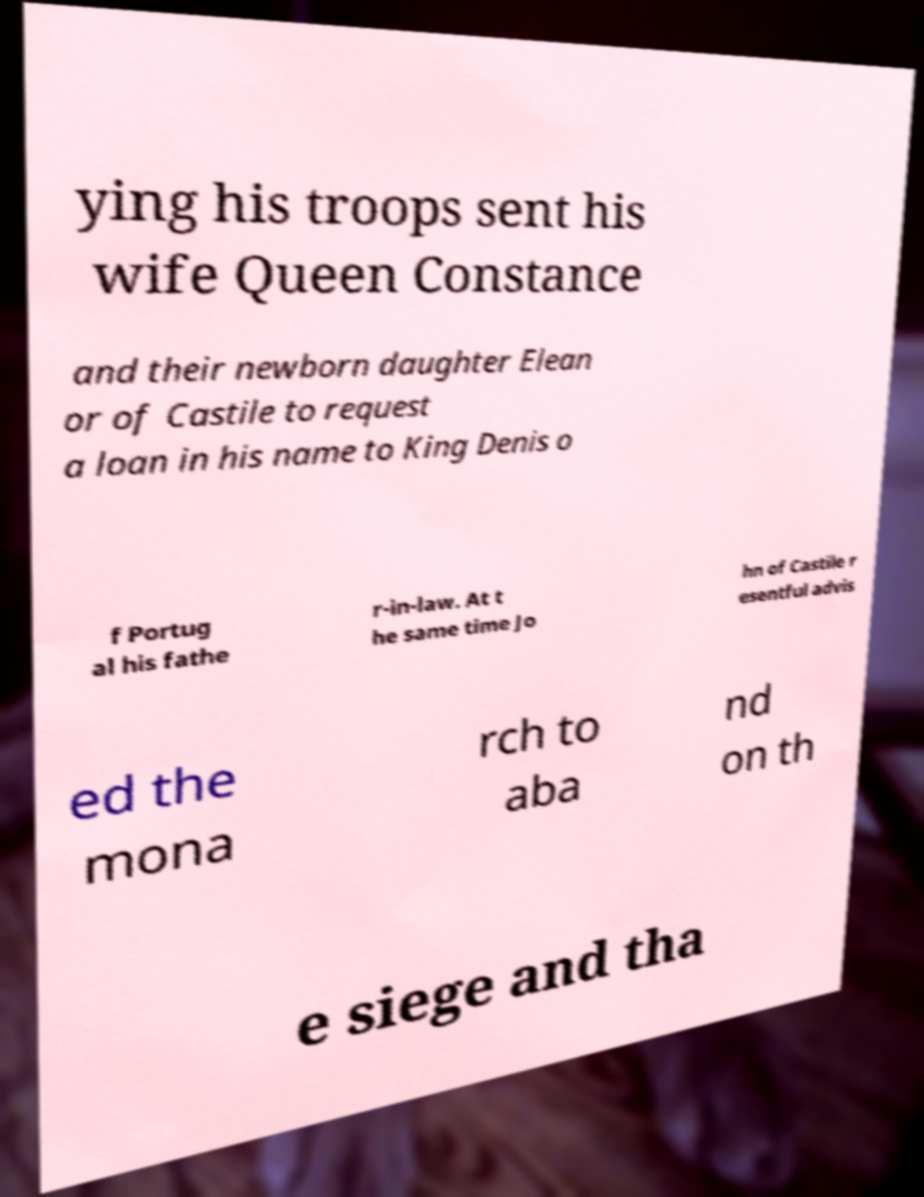For documentation purposes, I need the text within this image transcribed. Could you provide that? ying his troops sent his wife Queen Constance and their newborn daughter Elean or of Castile to request a loan in his name to King Denis o f Portug al his fathe r-in-law. At t he same time Jo hn of Castile r esentful advis ed the mona rch to aba nd on th e siege and tha 